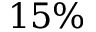<formula> <loc_0><loc_0><loc_500><loc_500>1 5 \%</formula> 